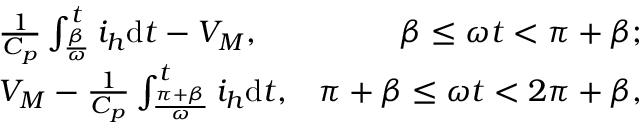<formula> <loc_0><loc_0><loc_500><loc_500>\begin{array} { r l r } & { \frac { 1 } { C _ { p } } \int _ { \frac { \beta } { \omega } } ^ { t } i _ { h } d t - { V _ { M } } , } & { \beta \leq \omega t < \pi + \beta ; } \\ & { { V _ { M } } - \frac { 1 } { C _ { p } } \int _ { \frac { \pi + \beta } { \omega } } ^ { t } i _ { h } d t , } & { \pi + \beta \leq \omega t < 2 \pi + \beta , } \end{array}</formula> 